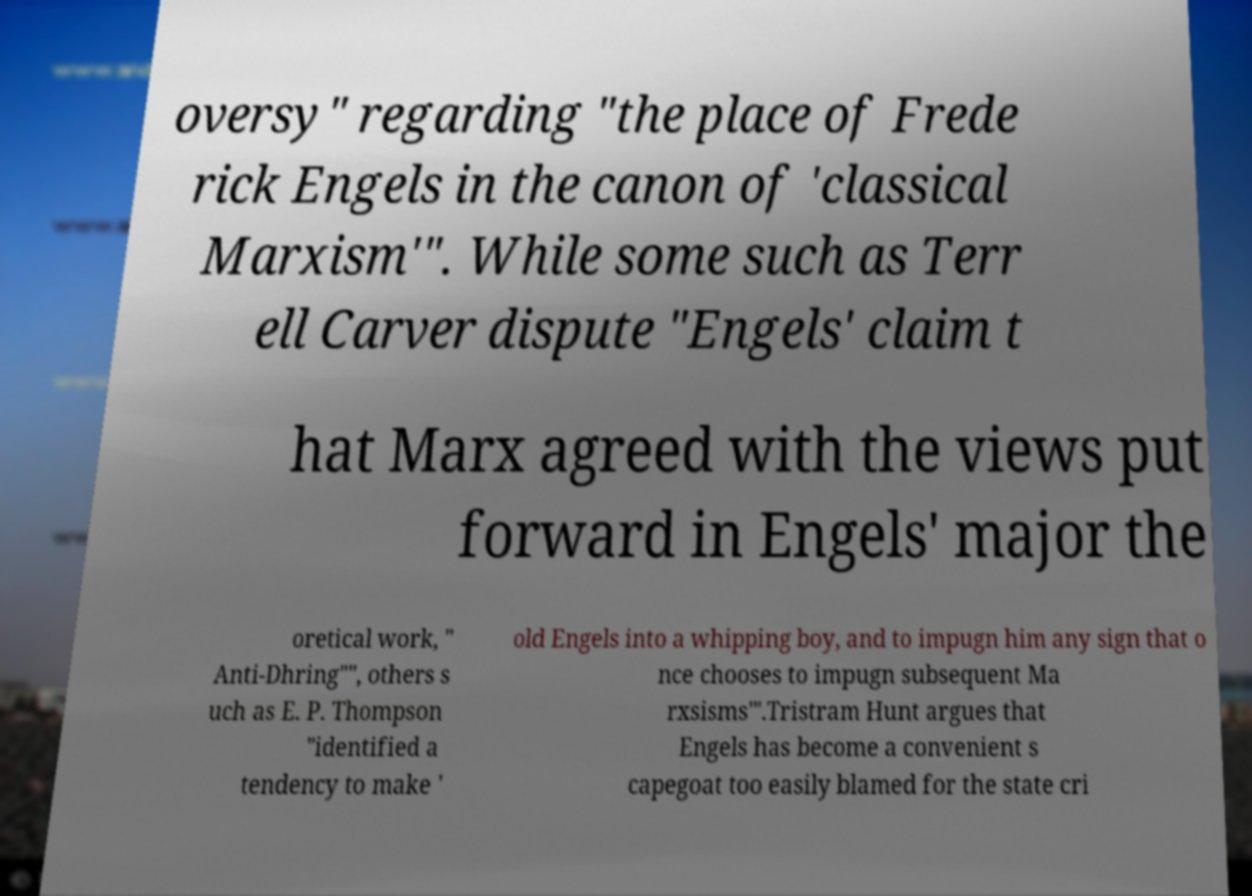Can you accurately transcribe the text from the provided image for me? oversy" regarding "the place of Frede rick Engels in the canon of 'classical Marxism'". While some such as Terr ell Carver dispute "Engels' claim t hat Marx agreed with the views put forward in Engels' major the oretical work, " Anti-Dhring"", others s uch as E. P. Thompson "identified a tendency to make ' old Engels into a whipping boy, and to impugn him any sign that o nce chooses to impugn subsequent Ma rxsisms'".Tristram Hunt argues that Engels has become a convenient s capegoat too easily blamed for the state cri 